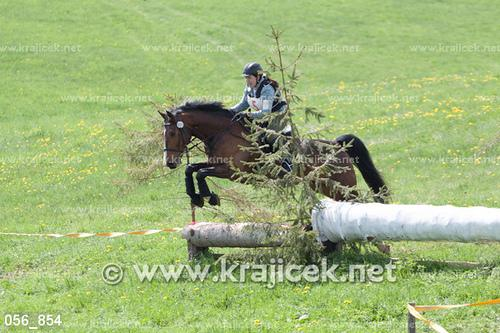Which animal is present in the picture and what activity is it engaged in? There is a brown horse present in the picture, which is jumping over a log with a rider on its back. List the key elements in the image, including any text present. Rider on a horse, white wrapping on a pole, orange rope, fur tree, wood poll, horse head, horse legs, horse tail, helmet, grass, yellow flowers, white flowers, number 854, number 5, copyright symbol, and the text "www.krajicek.net." Identify the person in the image and describe their activity and outfit. There is a man wearing a helmet riding a brown horse, which is jumping over a log in a grassy field with flowers. What is the primary focus of the image and what is happening in the scene? The main subject is a brown horse jumping over a log with a rider on it, surrounded by short green and yellow grass and yellow flowers in a field. What detail in the image appears to be a website or copyright information? There is text in the image that says "www.krajicek.net" and has a copyright symbol, indicating website or copyright information. Imagine this image being used to advertise a product. What type of product could it be promoting? (Product advertisement task) The image could be used to promote equestrian equipment, horse riding lessons, or an equestrian sports event or competition. Choose a task from the given list and summarize one aspect of the image related to it. (Visual Entailment task) Visual Entailment: The brown horse jumping over a log visually entails that there is an equestrian event or activity taking place. What kind of sport-related activity could be happening in this picture? The picture shows an equestrian event or horse riding activity, with a man riding a brown horse that is jumping over a log. In the image, describe the nature of the field and what kind of flowers can be seen in it. The field has short green and yellow grass and contains yellow and white flowers. 